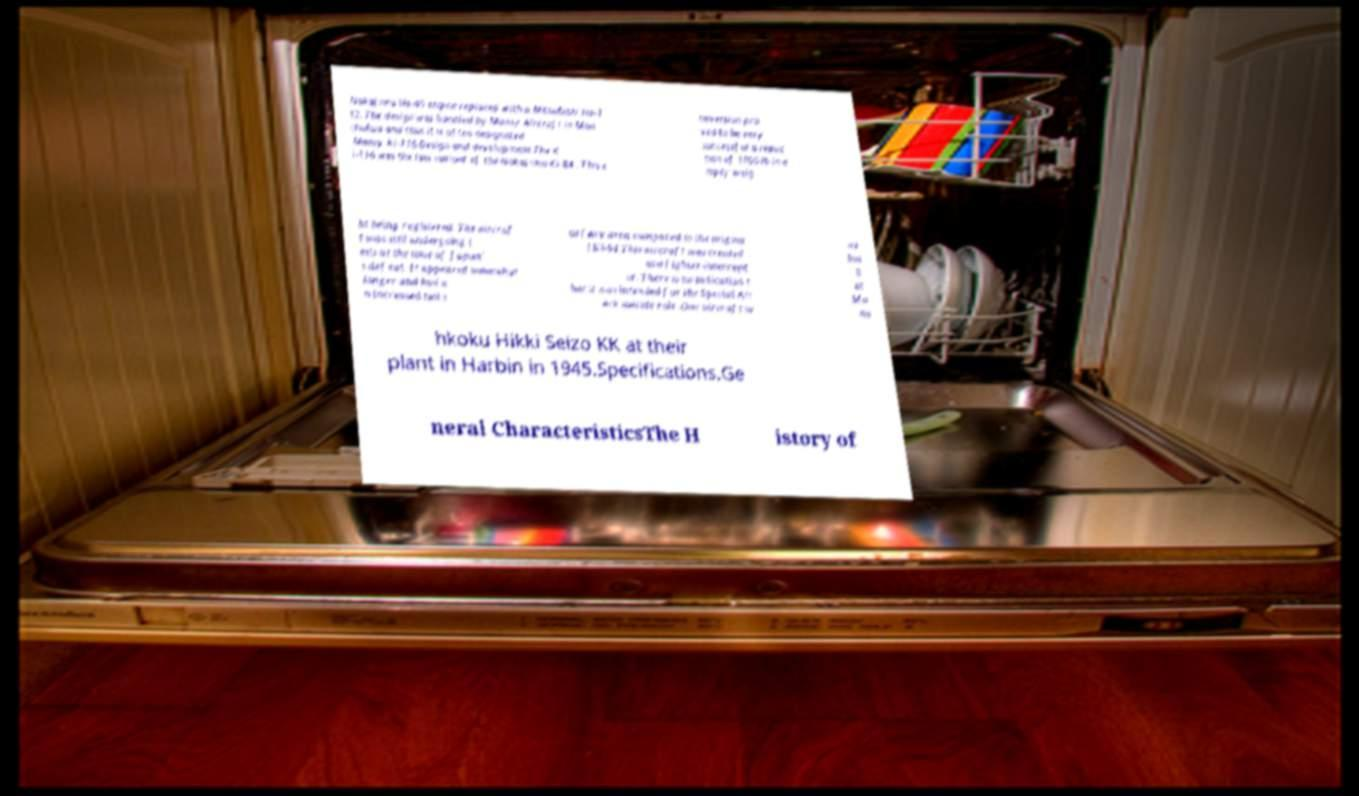There's text embedded in this image that I need extracted. Can you transcribe it verbatim? Nakajima Ha-45 engine replaced with a Mitsubishi Ha-1 12. The design was handled by Mansy Aircraft in Man chukuo and thus it is often designated Mansy Ki-116.Design and development.The K i-116 was the last variant of the Nakajima Ki-84 . This c onversion pro ved to be very successful a reduc tion of 1000 lb in e mpty weig ht being registered. The aircraf t was still undergoing t ests at the time of Japan' s defeat. It appeared somewhat longer and had a n increased tail s urface area compared to the origina l Ki-84.This aircraft was created as a fighter-intercept or. There is no indication t hat it was intended for the Special Att ack suicide role .One aircraft w as bui lt at Ma ns hkoku Hikki Seizo KK at their plant in Harbin in 1945.Specifications.Ge neral CharacteristicsThe H istory of 